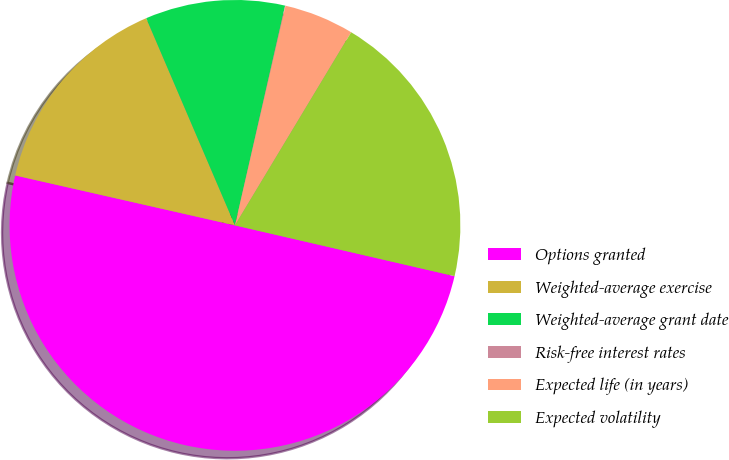Convert chart. <chart><loc_0><loc_0><loc_500><loc_500><pie_chart><fcel>Options granted<fcel>Weighted-average exercise<fcel>Weighted-average grant date<fcel>Risk-free interest rates<fcel>Expected life (in years)<fcel>Expected volatility<nl><fcel>49.93%<fcel>15.0%<fcel>10.01%<fcel>0.03%<fcel>5.02%<fcel>19.99%<nl></chart> 